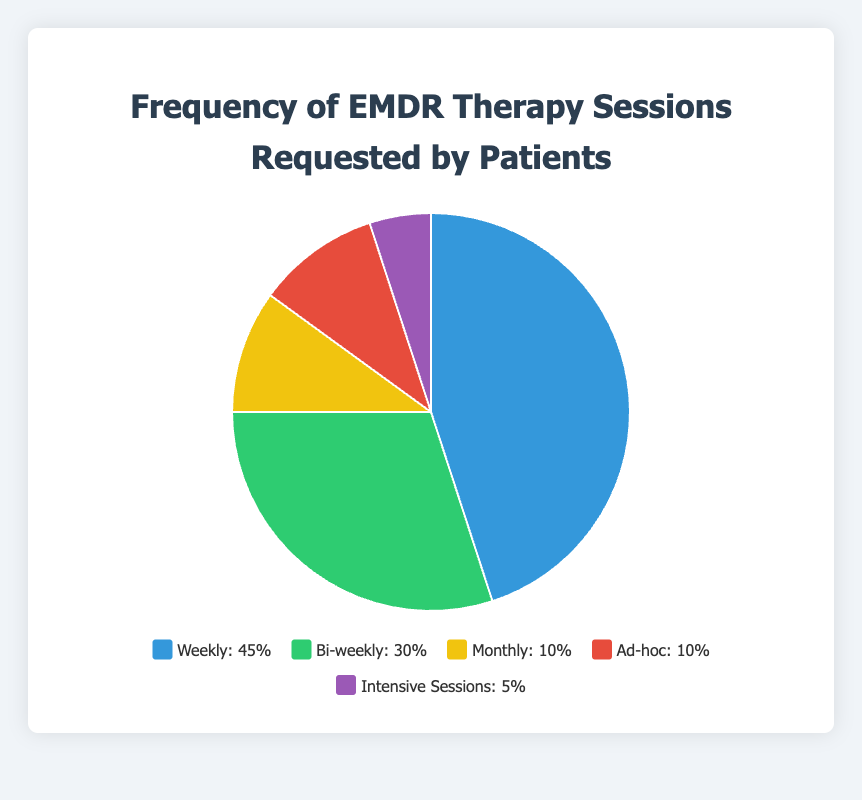Which session type is most frequently requested by patients? The segment with the highest percentage represents the most frequently requested session type. The "Weekly" session type has 45%, which is the highest.
Answer: Weekly How do the percentages of "Weekly" and "Ad-hoc" sessions compare? The "Weekly" sessions are 45% and "Ad-hoc" sessions are 10%. Comparison shows "Weekly" is greater.
Answer: Weekly is more frequent What is the total percentage of "Bi-weekly" and "Monthly" sessions combined? Sum the percentages: 30% (Bi-weekly) + 10% (Monthly) = 40%
Answer: 40% Are "Monthly" and "Ad-hoc" sessions requested equally? Both segments have the same percentage: 10%.
Answer: Yes Which session type is represented by the color blue in the chart? The color blue corresponds to the "Weekly" session type.
Answer: Weekly How much more frequently are "Weekly" sessions requested compared to "Intensive Sessions"? Subtract the percentage of "Intensive Sessions" from "Weekly": 45% - 5% = 40%
Answer: 40% more What percentage of patients request non-weekly sessions in total? Add percentages of non-weekly sessions: 30% (Bi-weekly) + 10% (Monthly) + 10% (Ad-hoc) + 5% (Intensive Sessions) = 55%
Answer: 55% Is there a session type requested by exactly 10% of the patients? Both "Monthly" and "Ad-hoc" sessions are requested by 10% of patients each.
Answer: Yes What is the difference in percentage between the most and least requested session types? Subtract the smallest percentage (5% for Intensive Sessions) from the largest (45% for Weekly): 45% - 5% = 40%
Answer: 40% 